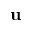Convert formula to latex. <formula><loc_0><loc_0><loc_500><loc_500>\mathbf u</formula> 